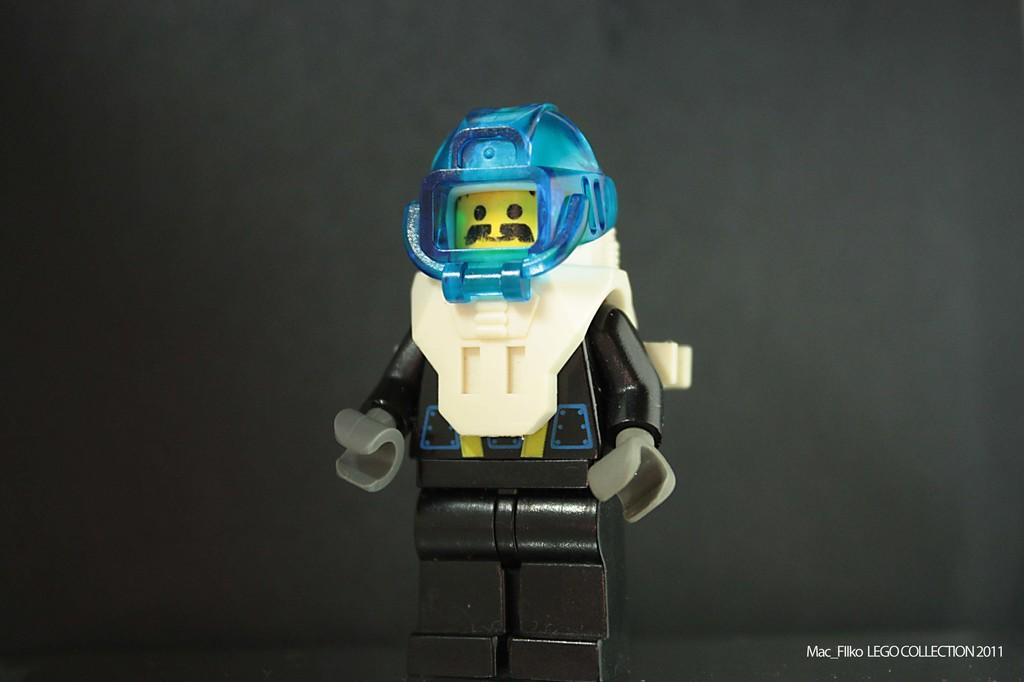What is the main subject of the image? The main subject of the image is a toy robot. What color is the toy robot? The toy robot is black in color. What additional feature can be seen on the toy robot? The toy robot has a blue helmet. What color is the background of the image? The background of the image is black. Are there any visible cobwebs on the toy robot in the image? There are no cobwebs present on the toy robot in the image. 